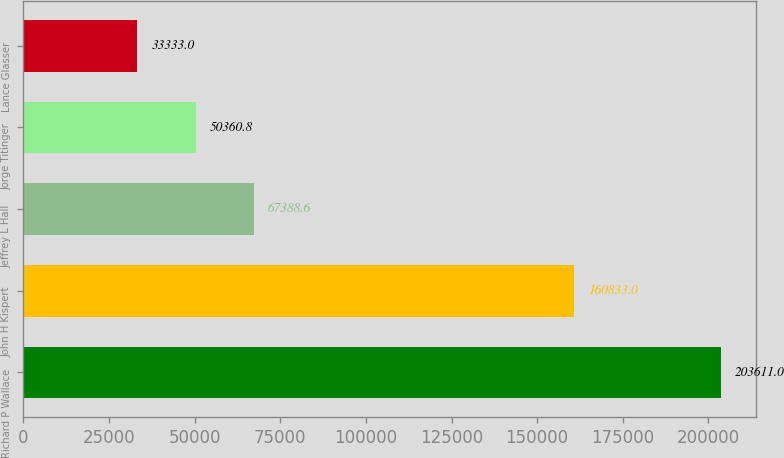Convert chart. <chart><loc_0><loc_0><loc_500><loc_500><bar_chart><fcel>Richard P Wallace<fcel>John H Kispert<fcel>Jeffrey L Hall<fcel>Jorge Titinger<fcel>Lance Glasser<nl><fcel>203611<fcel>160833<fcel>67388.6<fcel>50360.8<fcel>33333<nl></chart> 